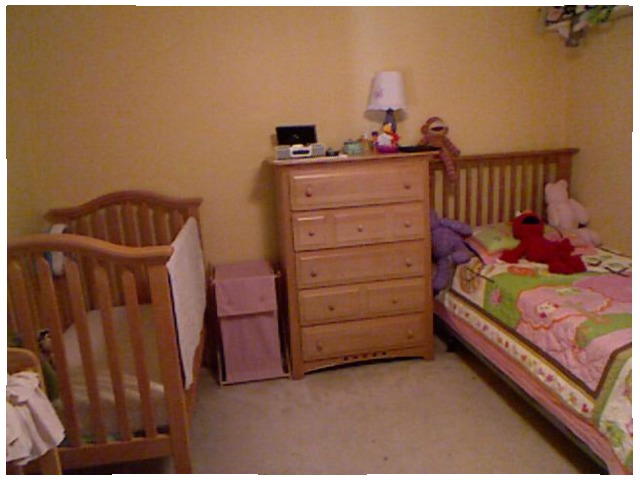<image>
Can you confirm if the lamp is on the dresser? Yes. Looking at the image, I can see the lamp is positioned on top of the dresser, with the dresser providing support. Where is the toy in relation to the bed? Is it on the bed? Yes. Looking at the image, I can see the toy is positioned on top of the bed, with the bed providing support. Where is the elmo in relation to the bed? Is it on the bed? Yes. Looking at the image, I can see the elmo is positioned on top of the bed, with the bed providing support. Where is the crib in relation to the elmo doll? Is it to the left of the elmo doll? Yes. From this viewpoint, the crib is positioned to the left side relative to the elmo doll. Is the blanket in the hamper? No. The blanket is not contained within the hamper. These objects have a different spatial relationship. 